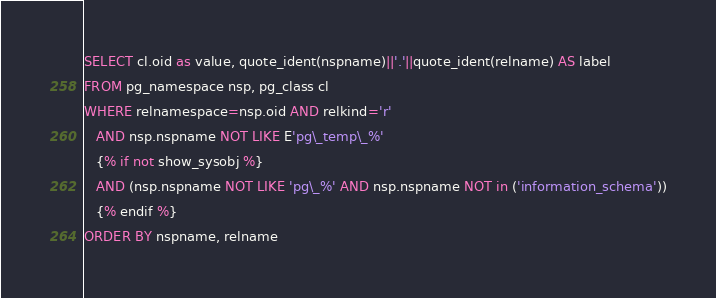<code> <loc_0><loc_0><loc_500><loc_500><_SQL_>SELECT cl.oid as value, quote_ident(nspname)||'.'||quote_ident(relname) AS label
FROM pg_namespace nsp, pg_class cl
WHERE relnamespace=nsp.oid AND relkind='r'
   AND nsp.nspname NOT LIKE E'pg\_temp\_%'
   {% if not show_sysobj %}
   AND (nsp.nspname NOT LIKE 'pg\_%' AND nsp.nspname NOT in ('information_schema'))
   {% endif %}
ORDER BY nspname, relname
</code> 